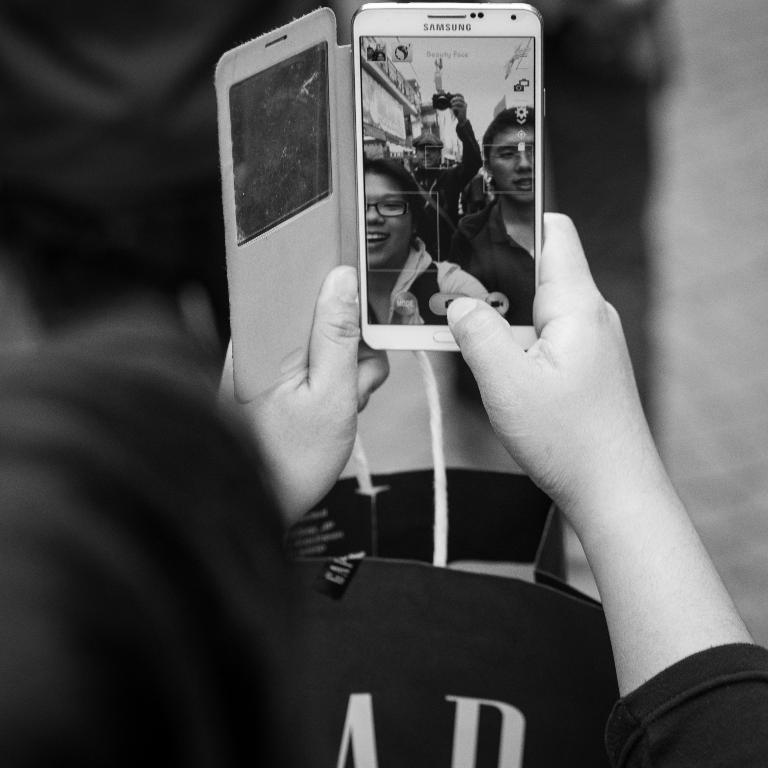<image>
Write a terse but informative summary of the picture. A women looks at a picture on her white Samsung phone. 